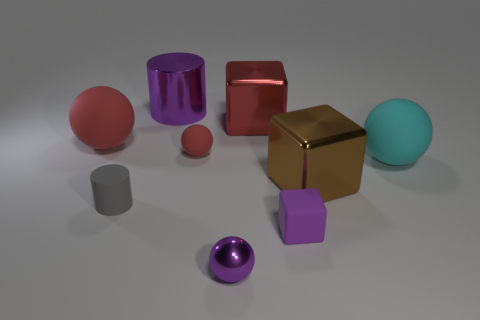Are there any other things that are the same size as the red shiny cube?
Provide a short and direct response. Yes. Do the tiny purple shiny thing and the small thing to the right of the small purple metallic ball have the same shape?
Provide a succinct answer. No. What material is the large cyan ball?
Your answer should be compact. Rubber. How many shiny things are either tiny balls or big purple cylinders?
Your answer should be compact. 2. Is the number of brown metallic objects that are behind the brown object less than the number of large purple metal objects on the right side of the tiny purple rubber block?
Offer a terse response. No. There is a metallic object that is in front of the block in front of the gray matte object; are there any large brown shiny blocks to the left of it?
Make the answer very short. No. What material is the small thing that is the same color as the tiny shiny sphere?
Provide a succinct answer. Rubber. Is the shape of the purple object that is to the left of the shiny sphere the same as the small purple object that is on the right side of the big red block?
Provide a short and direct response. No. What is the material of the red block that is the same size as the brown cube?
Your answer should be very brief. Metal. Are the large cyan sphere that is to the right of the small metal ball and the block that is in front of the gray thing made of the same material?
Provide a short and direct response. Yes. 